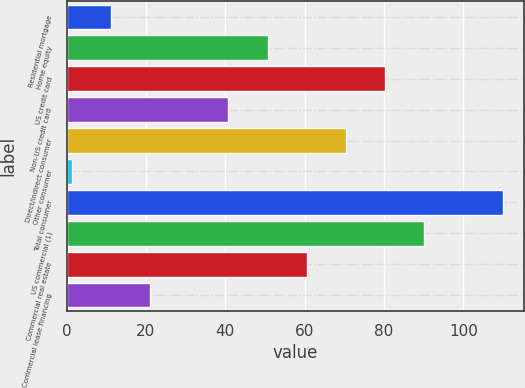Convert chart. <chart><loc_0><loc_0><loc_500><loc_500><bar_chart><fcel>Residential mortgage<fcel>Home equity<fcel>US credit card<fcel>Non-US credit card<fcel>Direct/Indirect consumer<fcel>Other consumer<fcel>Total consumer<fcel>US commercial (1)<fcel>Commercial real estate<fcel>Commercial lease financing<nl><fcel>11.17<fcel>50.65<fcel>80.26<fcel>40.78<fcel>70.39<fcel>1.3<fcel>109.87<fcel>90.13<fcel>60.52<fcel>21.04<nl></chart> 